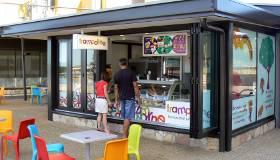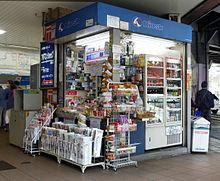The first image is the image on the left, the second image is the image on the right. For the images displayed, is the sentence "In the image on the left, at least 8 people are sitting at tables in the food court." factually correct? Answer yes or no. No. The first image is the image on the left, the second image is the image on the right. Evaluate the accuracy of this statement regarding the images: "At least one of the images includes a tree.". Is it true? Answer yes or no. No. 